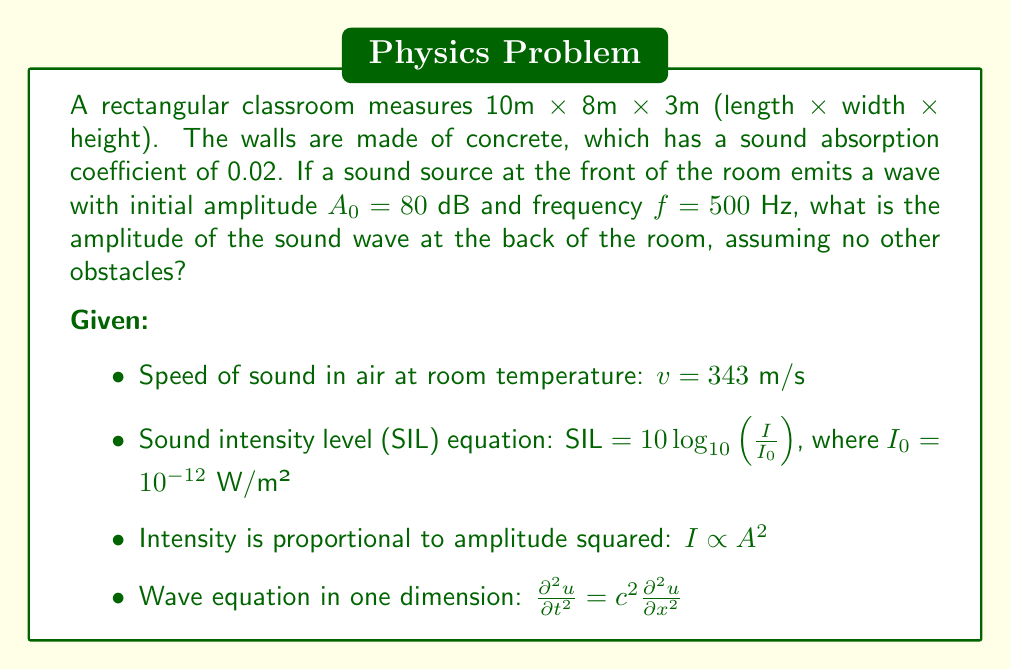Can you solve this math problem? To solve this problem, we'll follow these steps:

1) First, we need to calculate the wavelength of the sound:
   $$\lambda = \frac{v}{f} = \frac{343 \text{ m/s}}{500 \text{ Hz}} = 0.686 \text{ m}$$

2) The distance the wave travels is 10m (length of the room). The number of wavelengths is:
   $$n = \frac{10 \text{ m}}{0.686 \text{ m}} \approx 14.58$$

3) For each reflection off a surface, the wave loses energy. The energy remaining after each reflection is $(1-0.02) = 0.98$ of the original. Over the course of 14.58 wavelengths, the wave will reflect approximately 29 times (twice per wavelength).

4) The remaining energy after these reflections is:
   $$(0.98)^{29} \approx 0.5557$$

5) Since intensity is proportional to amplitude squared, and the energy is reduced to 0.5557 of the original, the new amplitude is:
   $$A = A_0 \sqrt{0.5557} \approx 0.7454A_0$$

6) To convert from dB to amplitude, we use the SIL equation:
   $$80 = 10 \log_{10}(\frac{I}{10^{-12}})$$
   $$I = 10^{-4} \text{ W/m²}$$

7) The new intensity is:
   $$I_{new} = 0.5557 \times 10^{-4} = 5.557 \times 10^{-5} \text{ W/m²}$$

8) Converting back to dB:
   $$SIL_{new} = 10 \log_{10}(\frac{5.557 \times 10^{-5}}{10^{-12}}) \approx 77.45 \text{ dB}$$

Therefore, the amplitude of the sound wave at the back of the room is approximately 77.45 dB.
Answer: 77.45 dB 